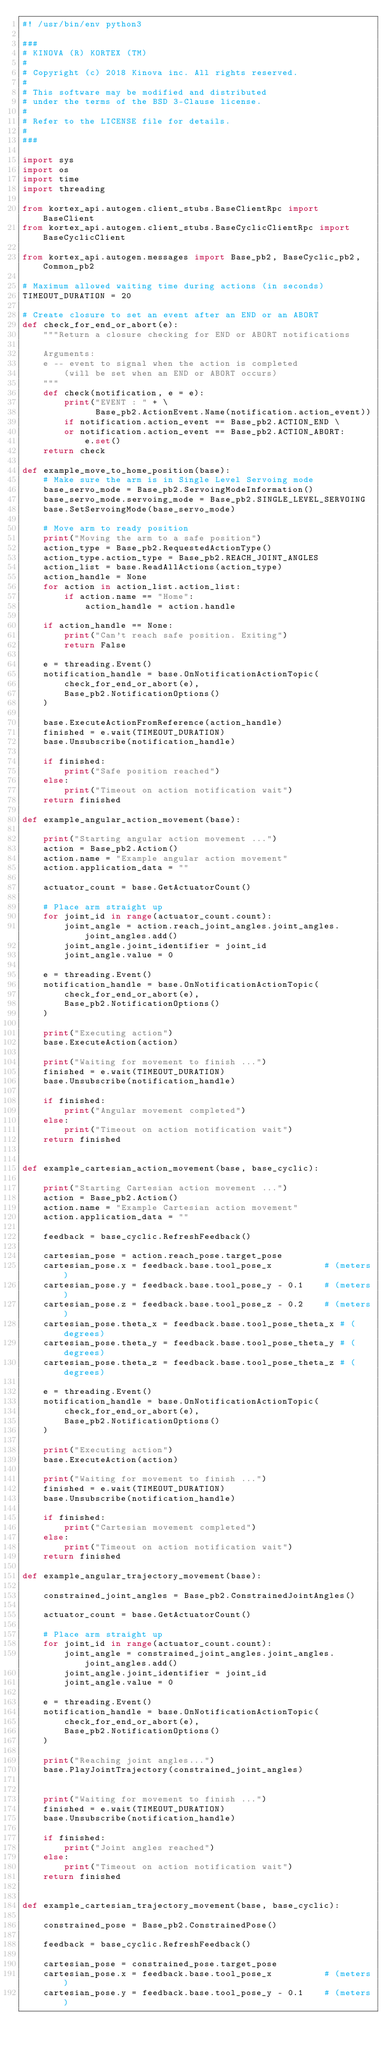Convert code to text. <code><loc_0><loc_0><loc_500><loc_500><_Python_>#! /usr/bin/env python3

###
# KINOVA (R) KORTEX (TM)
#
# Copyright (c) 2018 Kinova inc. All rights reserved.
#
# This software may be modified and distributed
# under the terms of the BSD 3-Clause license.
#
# Refer to the LICENSE file for details.
#
###

import sys
import os
import time
import threading

from kortex_api.autogen.client_stubs.BaseClientRpc import BaseClient
from kortex_api.autogen.client_stubs.BaseCyclicClientRpc import BaseCyclicClient

from kortex_api.autogen.messages import Base_pb2, BaseCyclic_pb2, Common_pb2

# Maximum allowed waiting time during actions (in seconds)
TIMEOUT_DURATION = 20

# Create closure to set an event after an END or an ABORT
def check_for_end_or_abort(e):
    """Return a closure checking for END or ABORT notifications

    Arguments:
    e -- event to signal when the action is completed
        (will be set when an END or ABORT occurs)
    """
    def check(notification, e = e):
        print("EVENT : " + \
              Base_pb2.ActionEvent.Name(notification.action_event))
        if notification.action_event == Base_pb2.ACTION_END \
        or notification.action_event == Base_pb2.ACTION_ABORT:
            e.set()
    return check
 
def example_move_to_home_position(base):
    # Make sure the arm is in Single Level Servoing mode
    base_servo_mode = Base_pb2.ServoingModeInformation()
    base_servo_mode.servoing_mode = Base_pb2.SINGLE_LEVEL_SERVOING
    base.SetServoingMode(base_servo_mode)
    
    # Move arm to ready position
    print("Moving the arm to a safe position")
    action_type = Base_pb2.RequestedActionType()
    action_type.action_type = Base_pb2.REACH_JOINT_ANGLES
    action_list = base.ReadAllActions(action_type)
    action_handle = None
    for action in action_list.action_list:
        if action.name == "Home":
            action_handle = action.handle

    if action_handle == None:
        print("Can't reach safe position. Exiting")
        return False

    e = threading.Event()
    notification_handle = base.OnNotificationActionTopic(
        check_for_end_or_abort(e),
        Base_pb2.NotificationOptions()
    )

    base.ExecuteActionFromReference(action_handle)
    finished = e.wait(TIMEOUT_DURATION)
    base.Unsubscribe(notification_handle)

    if finished:
        print("Safe position reached")
    else:
        print("Timeout on action notification wait")
    return finished

def example_angular_action_movement(base):
    
    print("Starting angular action movement ...")
    action = Base_pb2.Action()
    action.name = "Example angular action movement"
    action.application_data = ""

    actuator_count = base.GetActuatorCount()

    # Place arm straight up
    for joint_id in range(actuator_count.count):
        joint_angle = action.reach_joint_angles.joint_angles.joint_angles.add()
        joint_angle.joint_identifier = joint_id
        joint_angle.value = 0

    e = threading.Event()
    notification_handle = base.OnNotificationActionTopic(
        check_for_end_or_abort(e),
        Base_pb2.NotificationOptions()
    )
    
    print("Executing action")
    base.ExecuteAction(action)

    print("Waiting for movement to finish ...")
    finished = e.wait(TIMEOUT_DURATION)
    base.Unsubscribe(notification_handle)

    if finished:
        print("Angular movement completed")
    else:
        print("Timeout on action notification wait")
    return finished


def example_cartesian_action_movement(base, base_cyclic):
    
    print("Starting Cartesian action movement ...")
    action = Base_pb2.Action()
    action.name = "Example Cartesian action movement"
    action.application_data = ""

    feedback = base_cyclic.RefreshFeedback()

    cartesian_pose = action.reach_pose.target_pose
    cartesian_pose.x = feedback.base.tool_pose_x          # (meters)
    cartesian_pose.y = feedback.base.tool_pose_y - 0.1    # (meters)
    cartesian_pose.z = feedback.base.tool_pose_z - 0.2    # (meters)
    cartesian_pose.theta_x = feedback.base.tool_pose_theta_x # (degrees)
    cartesian_pose.theta_y = feedback.base.tool_pose_theta_y # (degrees)
    cartesian_pose.theta_z = feedback.base.tool_pose_theta_z # (degrees)

    e = threading.Event()
    notification_handle = base.OnNotificationActionTopic(
        check_for_end_or_abort(e),
        Base_pb2.NotificationOptions()
    )

    print("Executing action")
    base.ExecuteAction(action)

    print("Waiting for movement to finish ...")
    finished = e.wait(TIMEOUT_DURATION)
    base.Unsubscribe(notification_handle)

    if finished:
        print("Cartesian movement completed")
    else:
        print("Timeout on action notification wait")
    return finished

def example_angular_trajectory_movement(base):
    
    constrained_joint_angles = Base_pb2.ConstrainedJointAngles()

    actuator_count = base.GetActuatorCount()

    # Place arm straight up
    for joint_id in range(actuator_count.count):
        joint_angle = constrained_joint_angles.joint_angles.joint_angles.add()
        joint_angle.joint_identifier = joint_id
        joint_angle.value = 0

    e = threading.Event()
    notification_handle = base.OnNotificationActionTopic(
        check_for_end_or_abort(e),
        Base_pb2.NotificationOptions()
    )

    print("Reaching joint angles...")
    base.PlayJointTrajectory(constrained_joint_angles)


    print("Waiting for movement to finish ...")
    finished = e.wait(TIMEOUT_DURATION)
    base.Unsubscribe(notification_handle)

    if finished:
        print("Joint angles reached")
    else:
        print("Timeout on action notification wait")
    return finished


def example_cartesian_trajectory_movement(base, base_cyclic):
    
    constrained_pose = Base_pb2.ConstrainedPose()

    feedback = base_cyclic.RefreshFeedback()

    cartesian_pose = constrained_pose.target_pose
    cartesian_pose.x = feedback.base.tool_pose_x          # (meters)
    cartesian_pose.y = feedback.base.tool_pose_y - 0.1    # (meters)</code> 